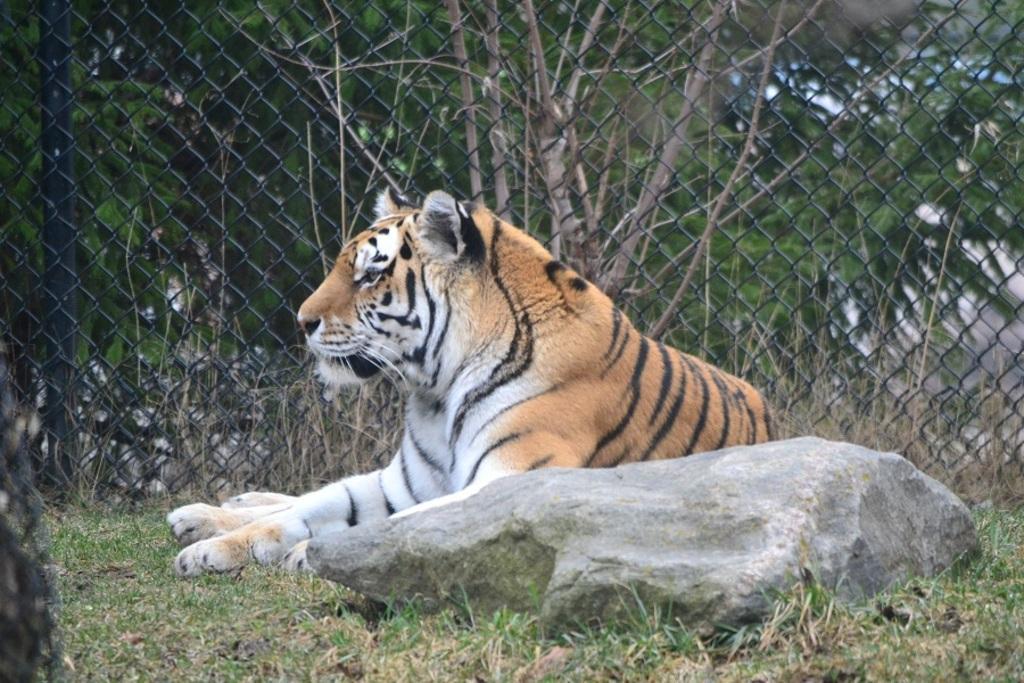In one or two sentences, can you explain what this image depicts? In this image we can see a tiger. We can also see the stone. In the background there is fence and behind the fence we can see the trees and also dried grass. At the bottom we can see the grass. 